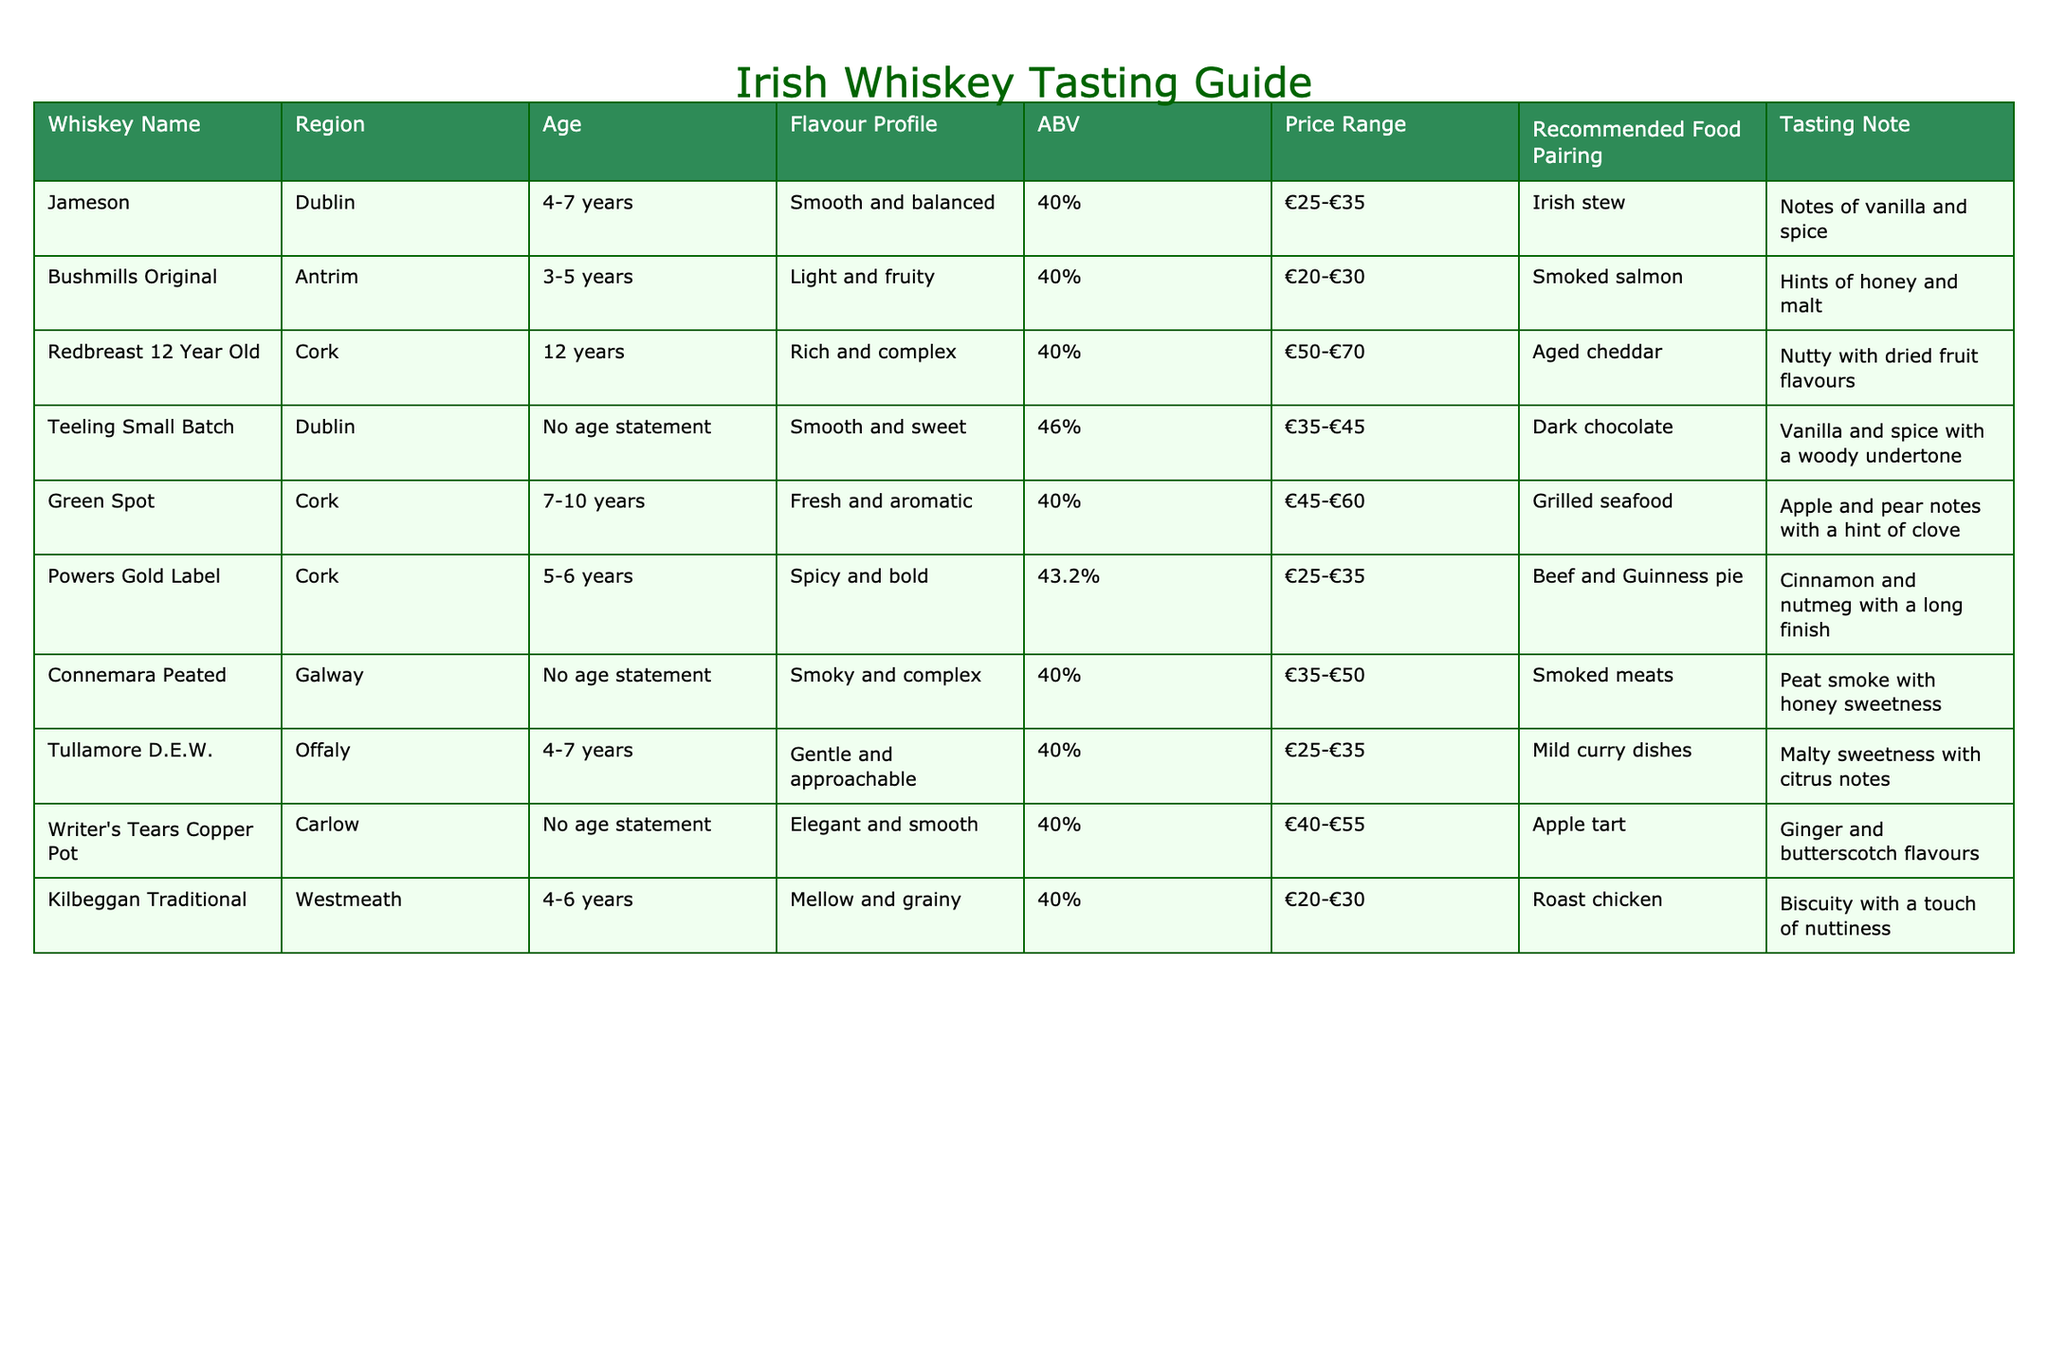What is the flavor profile of Redbreast 12 Year Old? The table shows that Redbreast 12 Year Old has a flavor profile described as "Rich and complex."
Answer: Rich and complex Which whiskey has the highest price range? By examining the price ranges listed in the table, Redbreast 12 Year Old is priced at €50-€70, which is the highest compared to the others.
Answer: €50-€70 Is Teeling Small Batch aged? The table indicates that Teeling Small Batch has "No age statement," meaning it is not aged for a specific period.
Answer: No What whiskey has a recommended food pairing of grilled seafood? The table shows that Green Spot is the whiskey with a recommended food pairing of grilled seafood.
Answer: Green Spot What is the average ABV of the whiskeys listed? To find the average ABV, we sum the ABV values (40% + 40% + 40% + 46% + 40% + 43.2% + 40% + 40% + 40%) which equals 389.2%. There are 9 whiskeys, so the average ABV is 389.2% / 9 ≈ 43.24%.
Answer: 43.24% Which city has the whiskey with the maximum age? Redbreast 12 Year Old from Cork has the maximum age of 12 years compared to the others listed.
Answer: Cork Does Bushmills Original have an age statement? The table specifies that Bushmills Original has an age range of 3-5 years, which qualifies as having an age statement.
Answer: Yes Which whiskey is described as smooth and sweet? From the table, Teeling Small Batch is described as "Smooth and sweet."
Answer: Teeling Small Batch What is the primary flavor note in Powers Gold Label? The table notes that Powers Gold Label has a tasting note of "Cinnamon and nutmeg with a long finish," indicating those are the primary flavors.
Answer: Cinnamon and nutmeg 